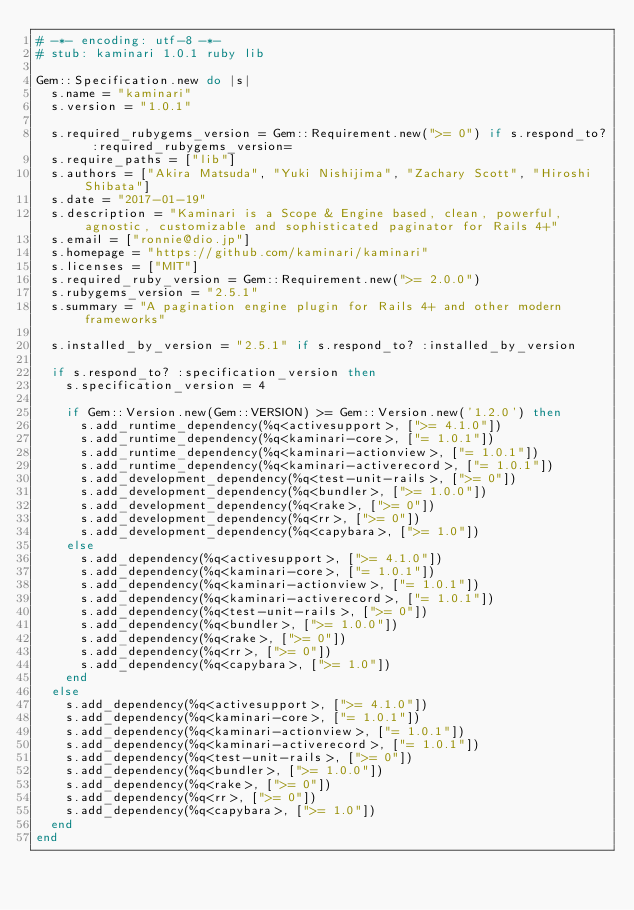Convert code to text. <code><loc_0><loc_0><loc_500><loc_500><_Ruby_># -*- encoding: utf-8 -*-
# stub: kaminari 1.0.1 ruby lib

Gem::Specification.new do |s|
  s.name = "kaminari"
  s.version = "1.0.1"

  s.required_rubygems_version = Gem::Requirement.new(">= 0") if s.respond_to? :required_rubygems_version=
  s.require_paths = ["lib"]
  s.authors = ["Akira Matsuda", "Yuki Nishijima", "Zachary Scott", "Hiroshi Shibata"]
  s.date = "2017-01-19"
  s.description = "Kaminari is a Scope & Engine based, clean, powerful, agnostic, customizable and sophisticated paginator for Rails 4+"
  s.email = ["ronnie@dio.jp"]
  s.homepage = "https://github.com/kaminari/kaminari"
  s.licenses = ["MIT"]
  s.required_ruby_version = Gem::Requirement.new(">= 2.0.0")
  s.rubygems_version = "2.5.1"
  s.summary = "A pagination engine plugin for Rails 4+ and other modern frameworks"

  s.installed_by_version = "2.5.1" if s.respond_to? :installed_by_version

  if s.respond_to? :specification_version then
    s.specification_version = 4

    if Gem::Version.new(Gem::VERSION) >= Gem::Version.new('1.2.0') then
      s.add_runtime_dependency(%q<activesupport>, [">= 4.1.0"])
      s.add_runtime_dependency(%q<kaminari-core>, ["= 1.0.1"])
      s.add_runtime_dependency(%q<kaminari-actionview>, ["= 1.0.1"])
      s.add_runtime_dependency(%q<kaminari-activerecord>, ["= 1.0.1"])
      s.add_development_dependency(%q<test-unit-rails>, [">= 0"])
      s.add_development_dependency(%q<bundler>, [">= 1.0.0"])
      s.add_development_dependency(%q<rake>, [">= 0"])
      s.add_development_dependency(%q<rr>, [">= 0"])
      s.add_development_dependency(%q<capybara>, [">= 1.0"])
    else
      s.add_dependency(%q<activesupport>, [">= 4.1.0"])
      s.add_dependency(%q<kaminari-core>, ["= 1.0.1"])
      s.add_dependency(%q<kaminari-actionview>, ["= 1.0.1"])
      s.add_dependency(%q<kaminari-activerecord>, ["= 1.0.1"])
      s.add_dependency(%q<test-unit-rails>, [">= 0"])
      s.add_dependency(%q<bundler>, [">= 1.0.0"])
      s.add_dependency(%q<rake>, [">= 0"])
      s.add_dependency(%q<rr>, [">= 0"])
      s.add_dependency(%q<capybara>, [">= 1.0"])
    end
  else
    s.add_dependency(%q<activesupport>, [">= 4.1.0"])
    s.add_dependency(%q<kaminari-core>, ["= 1.0.1"])
    s.add_dependency(%q<kaminari-actionview>, ["= 1.0.1"])
    s.add_dependency(%q<kaminari-activerecord>, ["= 1.0.1"])
    s.add_dependency(%q<test-unit-rails>, [">= 0"])
    s.add_dependency(%q<bundler>, [">= 1.0.0"])
    s.add_dependency(%q<rake>, [">= 0"])
    s.add_dependency(%q<rr>, [">= 0"])
    s.add_dependency(%q<capybara>, [">= 1.0"])
  end
end
</code> 